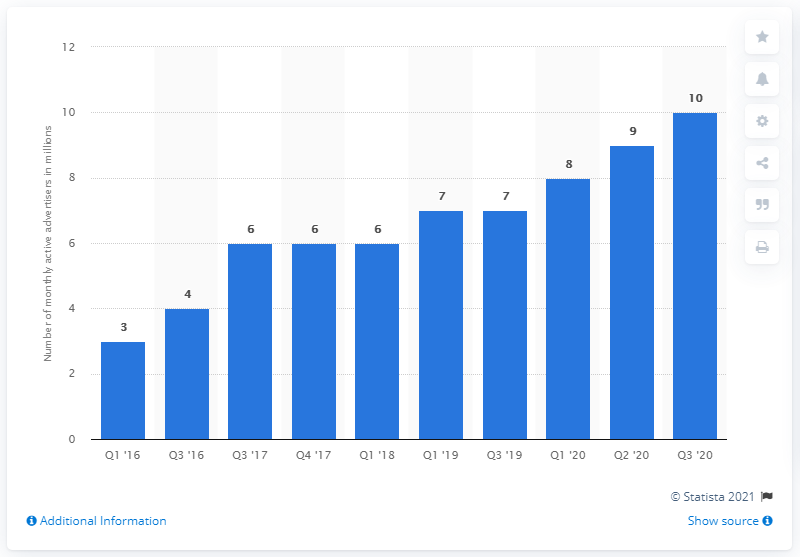Outline some significant characteristics in this image. In the third quarter of 2020, 10 advertisers were using Facebook. In the first quarter of the previous year, 10 advertisers were using Facebook. 